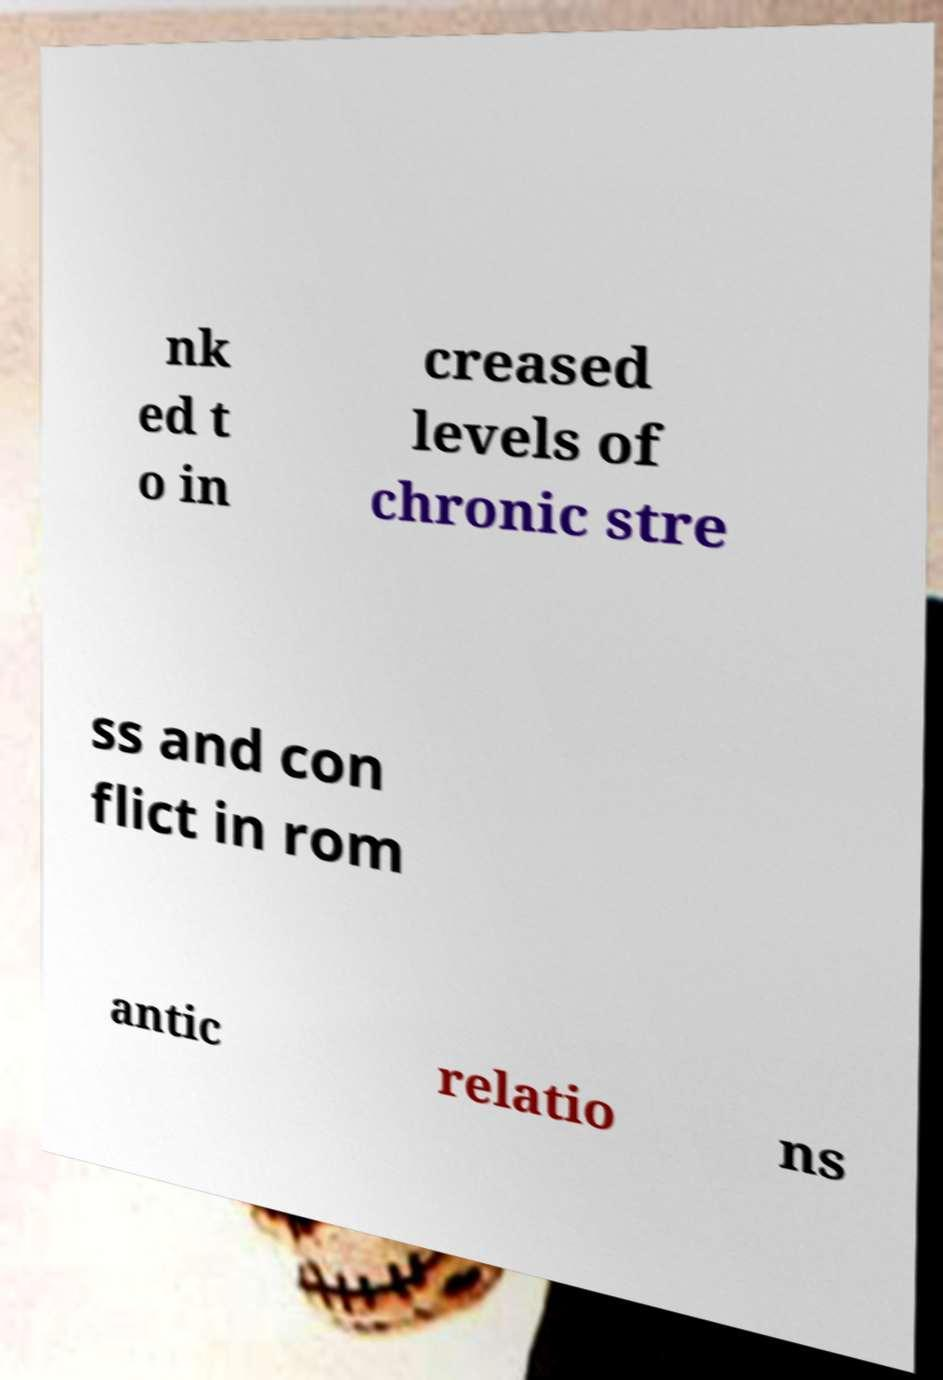Can you read and provide the text displayed in the image?This photo seems to have some interesting text. Can you extract and type it out for me? nk ed t o in creased levels of chronic stre ss and con flict in rom antic relatio ns 